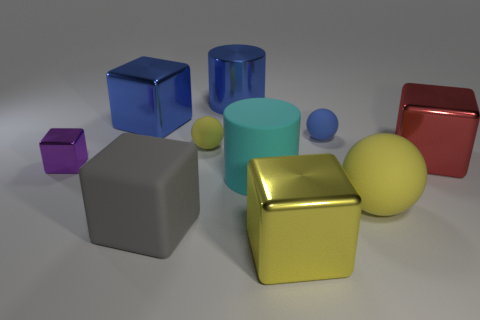Subtract all blue spheres. How many spheres are left? 2 Subtract all balls. How many objects are left? 7 Add 7 big purple balls. How many big purple balls exist? 7 Subtract all gray blocks. How many blocks are left? 4 Subtract 0 gray cylinders. How many objects are left? 10 Subtract 4 cubes. How many cubes are left? 1 Subtract all cyan balls. Subtract all gray cubes. How many balls are left? 3 Subtract all brown balls. How many purple cylinders are left? 0 Subtract all metallic cylinders. Subtract all large balls. How many objects are left? 8 Add 8 big gray rubber things. How many big gray rubber things are left? 9 